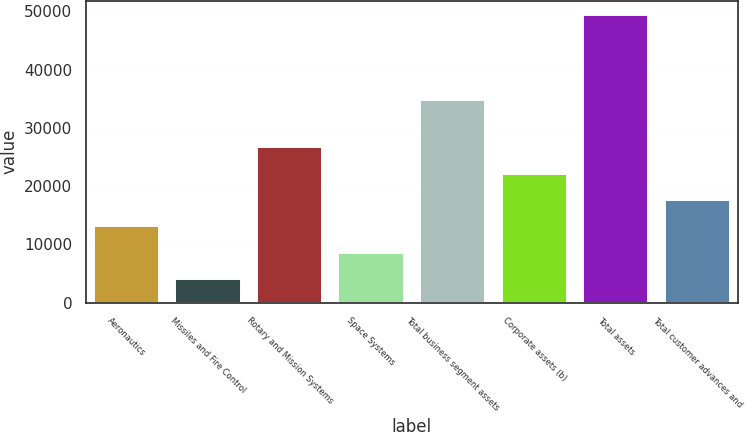Convert chart. <chart><loc_0><loc_0><loc_500><loc_500><bar_chart><fcel>Aeronautics<fcel>Missiles and Fire Control<fcel>Rotary and Mission Systems<fcel>Space Systems<fcel>Total business segment assets<fcel>Corporate assets (b)<fcel>Total assets<fcel>Total customer advances and<nl><fcel>13082.4<fcel>4027<fcel>26665.5<fcel>8554.7<fcel>34693<fcel>22137.8<fcel>49304<fcel>17610.1<nl></chart> 